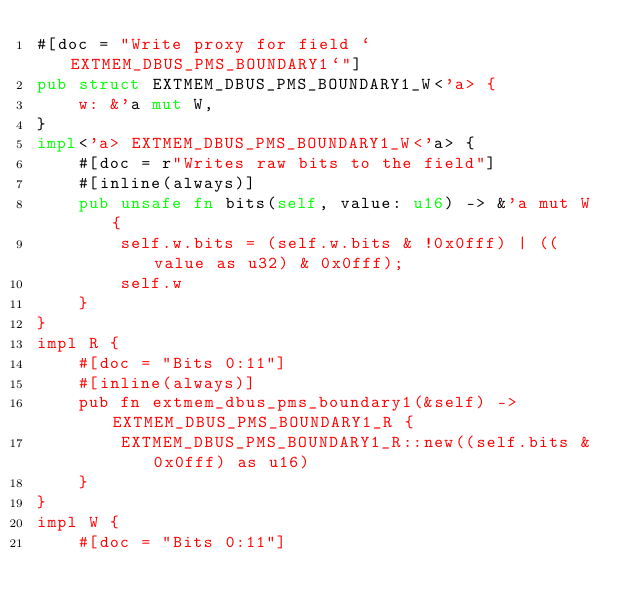<code> <loc_0><loc_0><loc_500><loc_500><_Rust_>#[doc = "Write proxy for field `EXTMEM_DBUS_PMS_BOUNDARY1`"]
pub struct EXTMEM_DBUS_PMS_BOUNDARY1_W<'a> {
    w: &'a mut W,
}
impl<'a> EXTMEM_DBUS_PMS_BOUNDARY1_W<'a> {
    #[doc = r"Writes raw bits to the field"]
    #[inline(always)]
    pub unsafe fn bits(self, value: u16) -> &'a mut W {
        self.w.bits = (self.w.bits & !0x0fff) | ((value as u32) & 0x0fff);
        self.w
    }
}
impl R {
    #[doc = "Bits 0:11"]
    #[inline(always)]
    pub fn extmem_dbus_pms_boundary1(&self) -> EXTMEM_DBUS_PMS_BOUNDARY1_R {
        EXTMEM_DBUS_PMS_BOUNDARY1_R::new((self.bits & 0x0fff) as u16)
    }
}
impl W {
    #[doc = "Bits 0:11"]</code> 